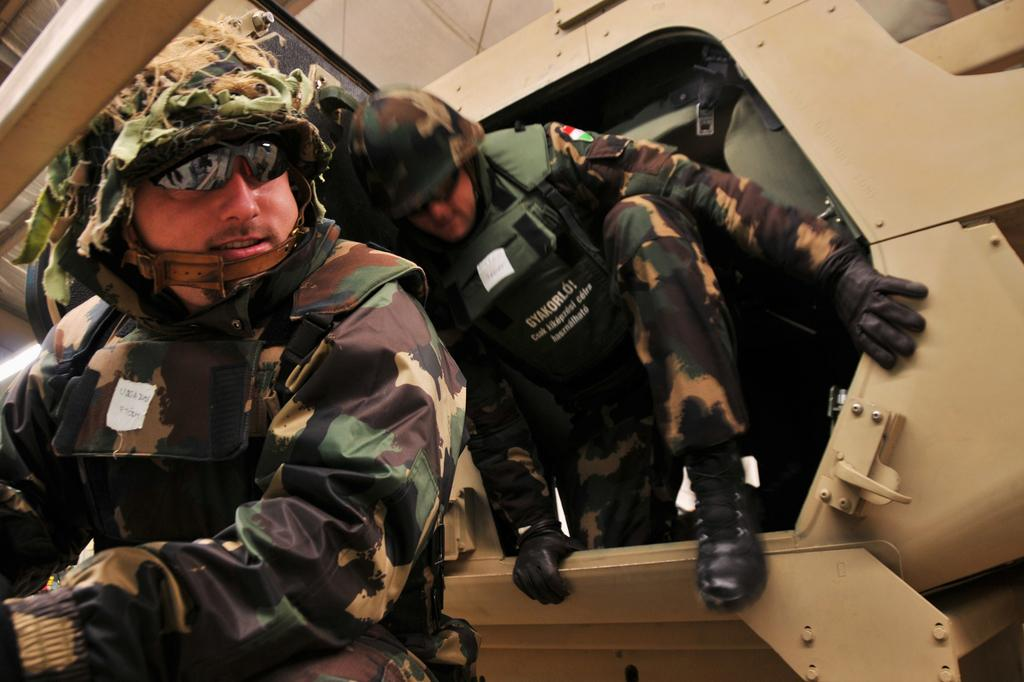How many people are in the foreground of the image? There are two persons in the foreground of the image. What can be seen in the background of the image? There is an aircraft in the background of the image. When was the image taken? The image was taken during the day. What type of bottle is being used by the men in the image? There are no men or bottles present in the image; it features two persons and an aircraft in the background. 